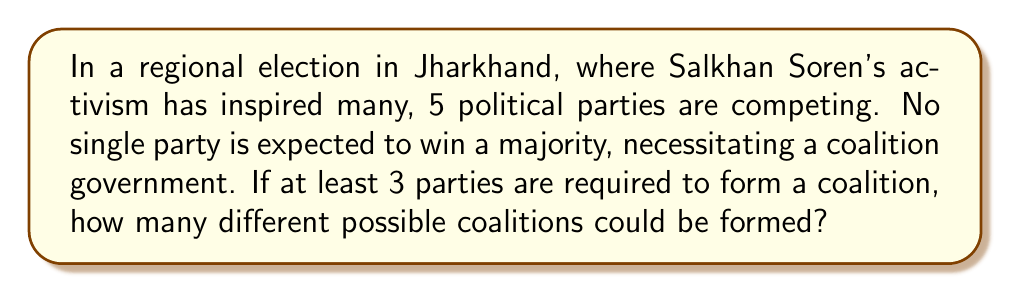Can you answer this question? Let's approach this step-by-step:

1) We have 5 parties in total, and we need to consider coalitions of 3, 4, or 5 parties.

2) For each case, we'll use the combination formula:
   $${n \choose r} = \frac{n!}{r!(n-r)!}$$
   where $n$ is the total number of parties and $r$ is the number in the coalition.

3) For 3-party coalitions:
   $${5 \choose 3} = \frac{5!}{3!(5-3)!} = \frac{5 \cdot 4 \cdot 3}{3 \cdot 2 \cdot 1} = 10$$

4) For 4-party coalitions:
   $${5 \choose 4} = \frac{5!}{4!(5-4)!} = \frac{5}{1} = 5$$

5) For 5-party coalition:
   $${5 \choose 5} = \frac{5!}{5!(5-5)!} = 1$$

6) The total number of possible coalitions is the sum of these:
   $$10 + 5 + 1 = 16$$

Therefore, there are 16 different possible coalitions that could be formed.
Answer: 16 possible coalitions 